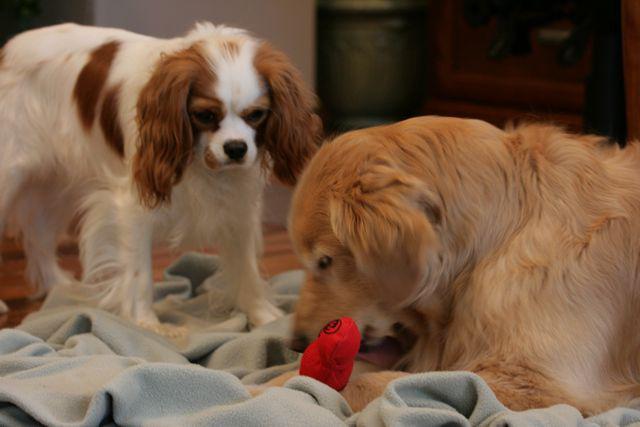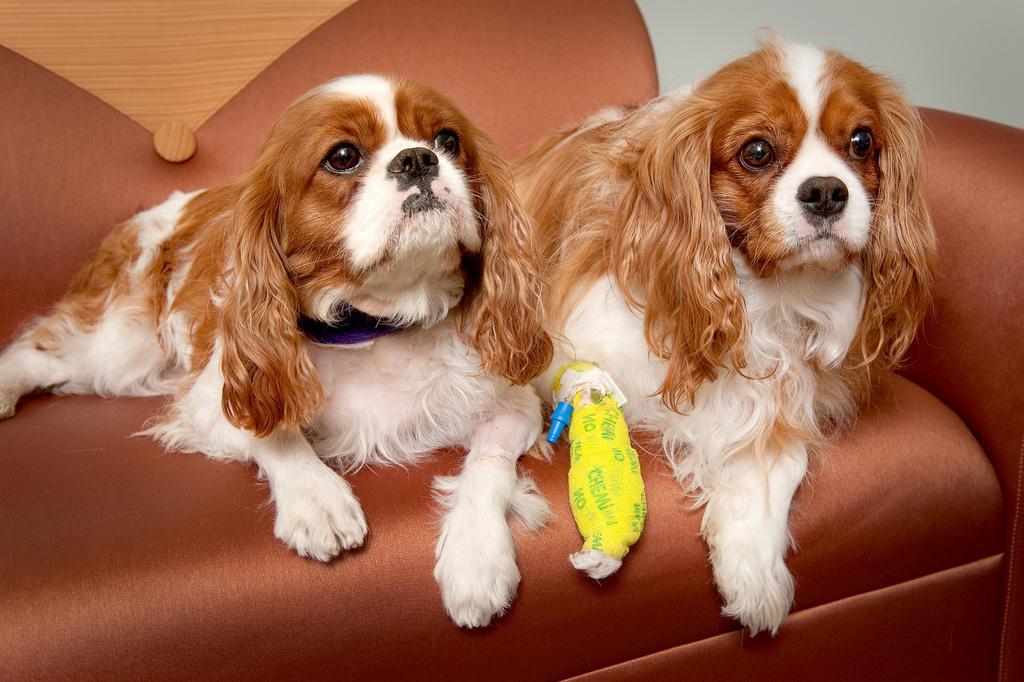The first image is the image on the left, the second image is the image on the right. For the images shown, is this caption "The right image contains at least two dogs." true? Answer yes or no. Yes. 